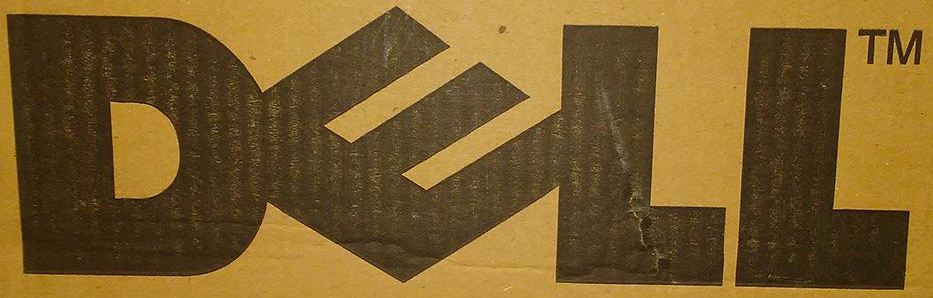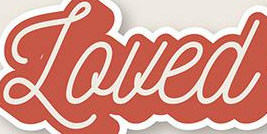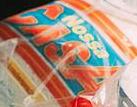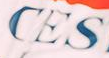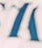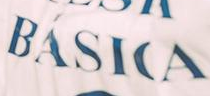What words are shown in these images in order, separated by a semicolon? DELL; Loued; CASA; CES; #; BÁSICA 